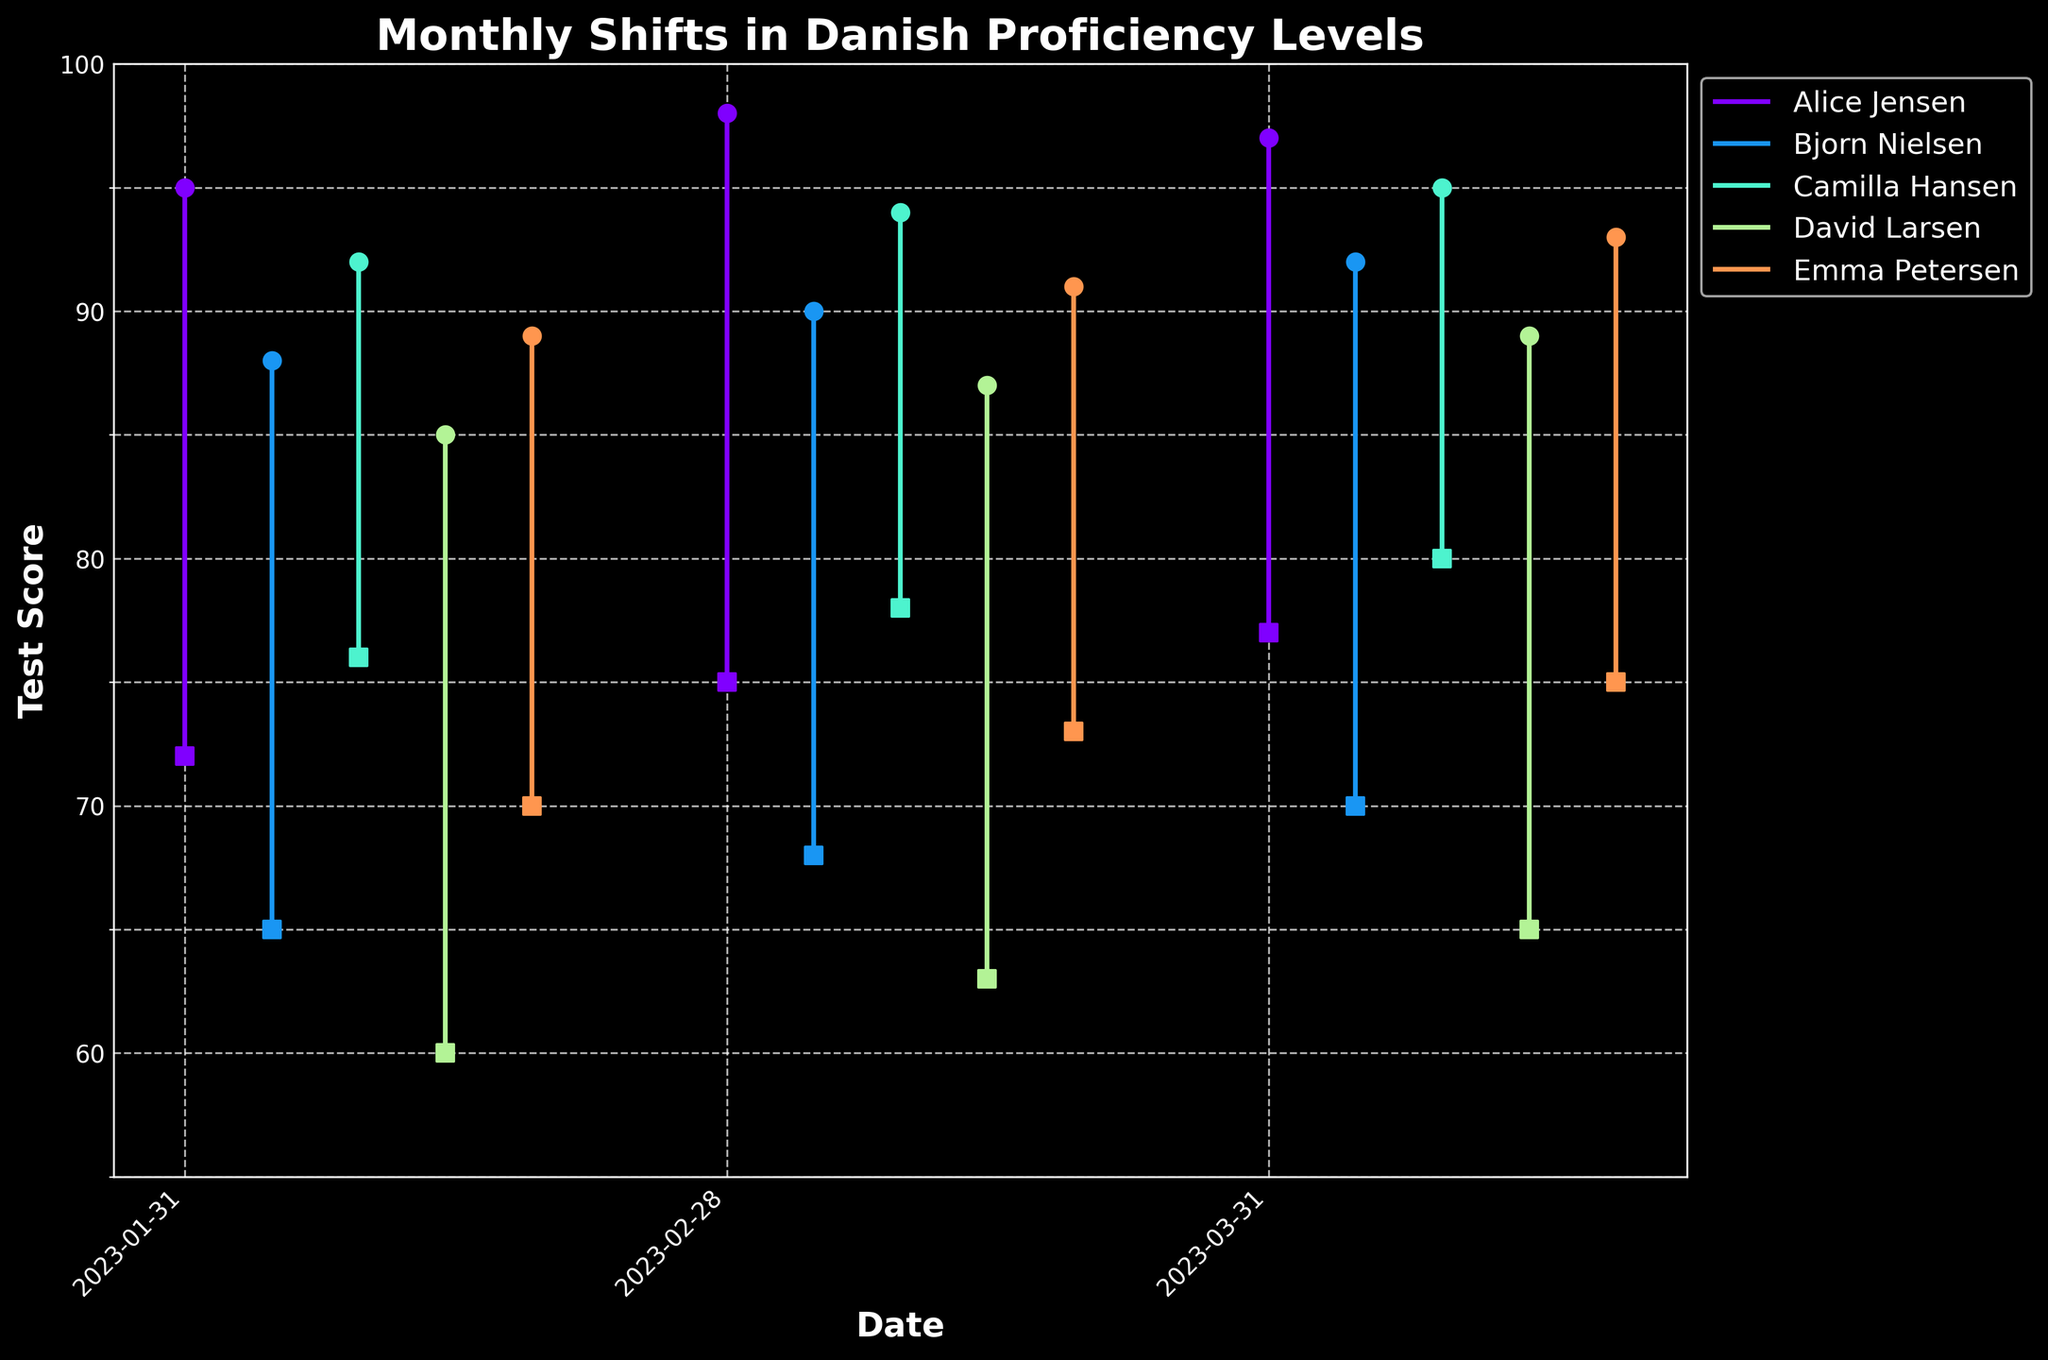What is the title of the candlestick plot? The title of the candlestick plot is usually located at the top of the chart. In this figure, it is 'Monthly Shifts in Danish Proficiency Levels'.
Answer: Monthly Shifts in Danish Proficiency Levels What is the highest test score achieved by Camilla Hansen in March 2023? To find Camilla Hansen's highest test score in March 2023, look for the relevant date and the vertical line corresponding to her data points with a scatter point marking the top value.
Answer: 95 Which student had the lowest test score in January 2023? Identify the student with the lowest marker (square) for January 2023. The axes and scatter plots can direct to the lowest value within that month's section.
Answer: David Larsen What is the average highest test score for Alice Jensen across the three months? Calculate the average by summing the highest test scores of Alice Jensen for January, February, and March, then divide by 3: (95 + 98 + 97) / 3.
Answer: 96.67 Which student showed the greatest increase in their lowest test score from January to March? Find the differences in the lowest test scores (lowest markers) for each student from January to March, and identify the maximum. For Alice Jensen, it's 77 - 72 = 5, for Bjorn Nielsen, 70 - 65 = 5, etc. Compare all.
Answer: Alice Jensen What is the range of test scores for Emma Petersen in February 2023? Subtract the lowest test score from the highest test score for Emma Petersen in February: 91 - 73.
Answer: 18 How many students scored above 90 as their highest score in March 2023? Count the number of students whose highest markers (circles) in March exceed the value of 90.
Answer: 4 Who has the smallest difference between their highest and lowest test scores in February 2023? Calculate the differences for each student in February and find the smallest. For Alice Jensen, it's 98 - 75 = 23, for Bjorn Nielsen, 90 - 68 = 22, etc. Compare all.
Answer: Camilla Hansen Did any student have a decrease in their highest test score from February to March? Compare the highest scores of each student between February and March to check for any decreases.
Answer: Yes, Alice Jensen Which month shows the highest overall test scores among all students? Sum the highest scores for all students for each month and compare the totals: January total, February total, March total. The month with the highest sum has the highest overall test scores.
Answer: March 